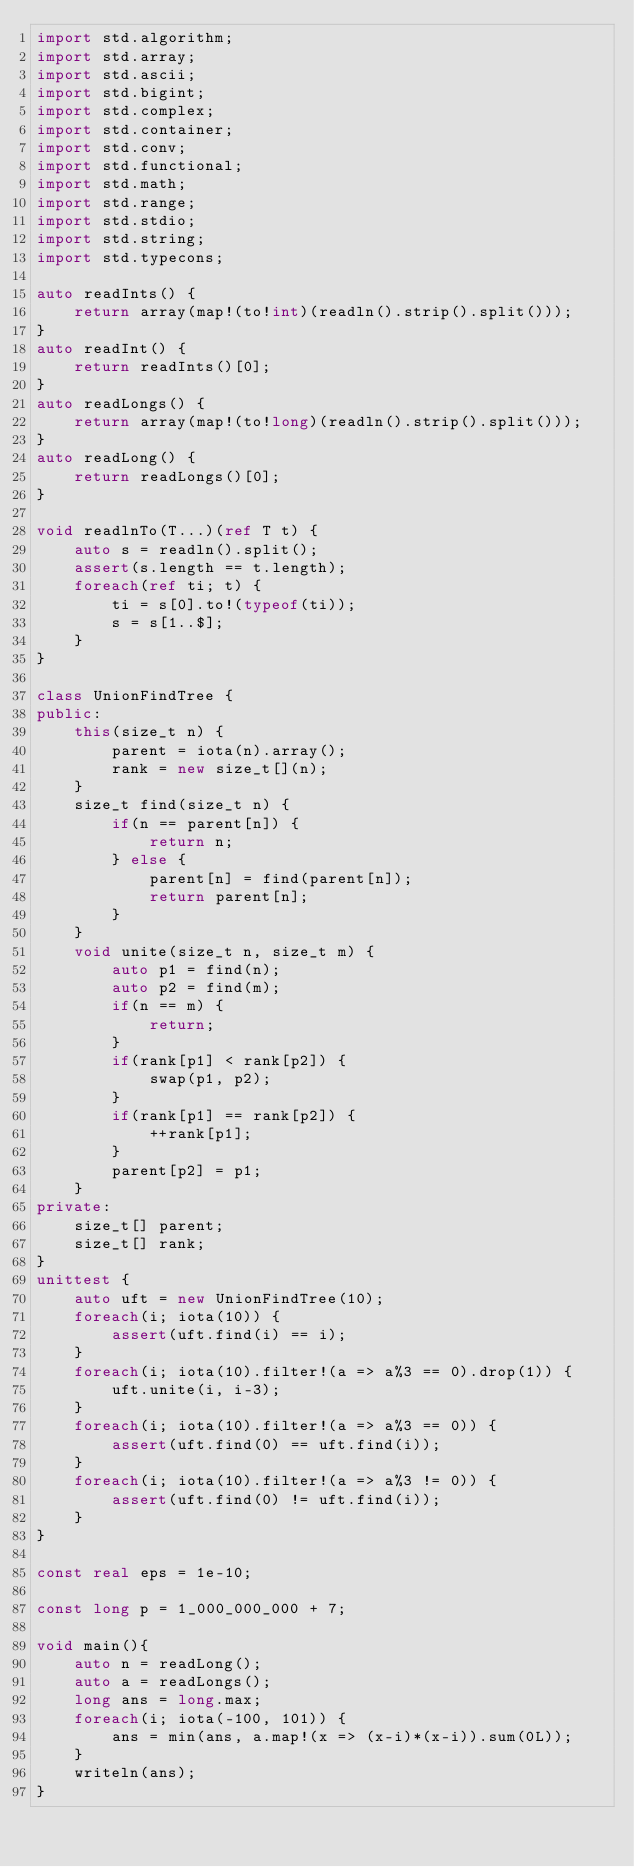Convert code to text. <code><loc_0><loc_0><loc_500><loc_500><_D_>import std.algorithm;
import std.array;
import std.ascii;
import std.bigint;
import std.complex;
import std.container;
import std.conv;
import std.functional;
import std.math;
import std.range;
import std.stdio;
import std.string;
import std.typecons;

auto readInts() {
	return array(map!(to!int)(readln().strip().split()));
}
auto readInt() {
	return readInts()[0];
}
auto readLongs() {
	return array(map!(to!long)(readln().strip().split()));
}
auto readLong() {
	return readLongs()[0];
}

void readlnTo(T...)(ref T t) {
    auto s = readln().split();
    assert(s.length == t.length);
    foreach(ref ti; t) {
        ti = s[0].to!(typeof(ti));
        s = s[1..$];
    }
}

class UnionFindTree {
public:
    this(size_t n) {
        parent = iota(n).array();
        rank = new size_t[](n);
    }
    size_t find(size_t n) {
        if(n == parent[n]) {
            return n;
        } else {
            parent[n] = find(parent[n]);
            return parent[n];
        }
    }
    void unite(size_t n, size_t m) {
        auto p1 = find(n);
        auto p2 = find(m);
        if(n == m) {
            return;
        }
        if(rank[p1] < rank[p2]) {
            swap(p1, p2);
        }
        if(rank[p1] == rank[p2]) {
            ++rank[p1];
        }
        parent[p2] = p1;
    }
private:
    size_t[] parent;
    size_t[] rank;
}
unittest {
    auto uft = new UnionFindTree(10);
    foreach(i; iota(10)) {
        assert(uft.find(i) == i);
    }
    foreach(i; iota(10).filter!(a => a%3 == 0).drop(1)) {
        uft.unite(i, i-3);
    }
    foreach(i; iota(10).filter!(a => a%3 == 0)) {
        assert(uft.find(0) == uft.find(i));
    }
    foreach(i; iota(10).filter!(a => a%3 != 0)) {
        assert(uft.find(0) != uft.find(i));
    }
}

const real eps = 1e-10;

const long p = 1_000_000_000 + 7;

void main(){
    auto n = readLong();
    auto a = readLongs();
    long ans = long.max;
    foreach(i; iota(-100, 101)) {
        ans = min(ans, a.map!(x => (x-i)*(x-i)).sum(0L));
    }
    writeln(ans);
}

</code> 